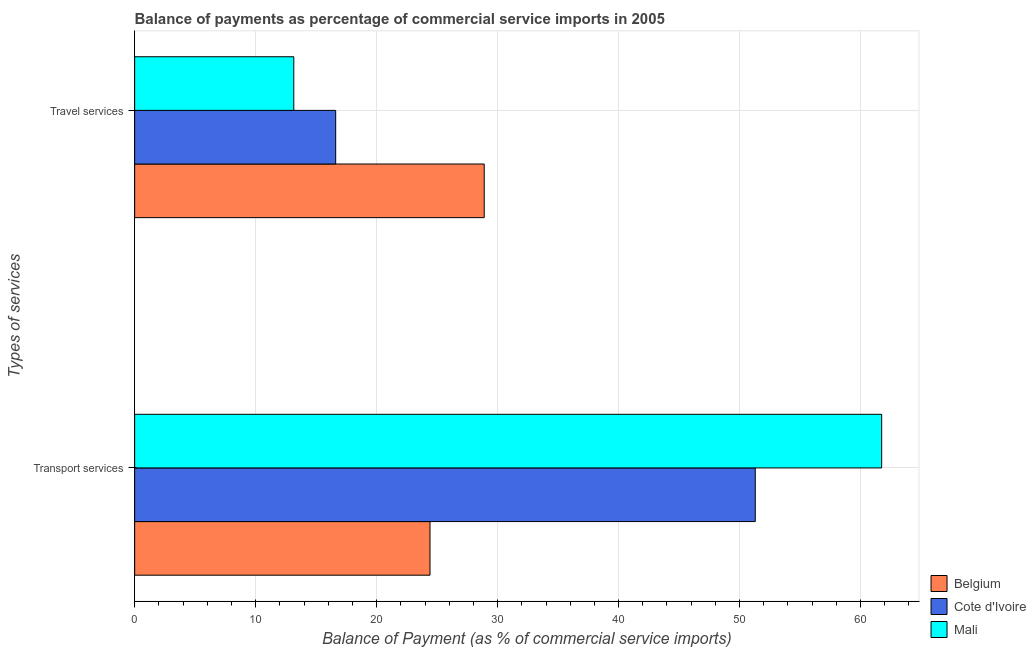How many groups of bars are there?
Your answer should be compact. 2. Are the number of bars per tick equal to the number of legend labels?
Provide a short and direct response. Yes. Are the number of bars on each tick of the Y-axis equal?
Ensure brevity in your answer.  Yes. How many bars are there on the 1st tick from the top?
Ensure brevity in your answer.  3. How many bars are there on the 1st tick from the bottom?
Provide a short and direct response. 3. What is the label of the 2nd group of bars from the top?
Make the answer very short. Transport services. What is the balance of payments of transport services in Belgium?
Give a very brief answer. 24.41. Across all countries, what is the maximum balance of payments of transport services?
Your response must be concise. 61.74. Across all countries, what is the minimum balance of payments of travel services?
Provide a succinct answer. 13.15. In which country was the balance of payments of transport services maximum?
Keep it short and to the point. Mali. In which country was the balance of payments of transport services minimum?
Offer a terse response. Belgium. What is the total balance of payments of travel services in the graph?
Your response must be concise. 58.66. What is the difference between the balance of payments of travel services in Cote d'Ivoire and that in Mali?
Ensure brevity in your answer.  3.46. What is the difference between the balance of payments of transport services in Belgium and the balance of payments of travel services in Mali?
Offer a very short reply. 11.26. What is the average balance of payments of travel services per country?
Provide a succinct answer. 19.55. What is the difference between the balance of payments of transport services and balance of payments of travel services in Cote d'Ivoire?
Provide a succinct answer. 34.68. In how many countries, is the balance of payments of transport services greater than 48 %?
Your response must be concise. 2. What is the ratio of the balance of payments of travel services in Mali to that in Cote d'Ivoire?
Ensure brevity in your answer.  0.79. What does the 2nd bar from the top in Transport services represents?
Ensure brevity in your answer.  Cote d'Ivoire. What does the 3rd bar from the bottom in Travel services represents?
Your answer should be very brief. Mali. How many bars are there?
Provide a succinct answer. 6. Are all the bars in the graph horizontal?
Provide a short and direct response. Yes. What is the difference between two consecutive major ticks on the X-axis?
Provide a short and direct response. 10. Does the graph contain grids?
Your response must be concise. Yes. How many legend labels are there?
Your answer should be very brief. 3. How are the legend labels stacked?
Offer a very short reply. Vertical. What is the title of the graph?
Ensure brevity in your answer.  Balance of payments as percentage of commercial service imports in 2005. What is the label or title of the X-axis?
Offer a terse response. Balance of Payment (as % of commercial service imports). What is the label or title of the Y-axis?
Provide a succinct answer. Types of services. What is the Balance of Payment (as % of commercial service imports) of Belgium in Transport services?
Ensure brevity in your answer.  24.41. What is the Balance of Payment (as % of commercial service imports) of Cote d'Ivoire in Transport services?
Your answer should be very brief. 51.3. What is the Balance of Payment (as % of commercial service imports) of Mali in Transport services?
Ensure brevity in your answer.  61.74. What is the Balance of Payment (as % of commercial service imports) of Belgium in Travel services?
Offer a very short reply. 28.89. What is the Balance of Payment (as % of commercial service imports) in Cote d'Ivoire in Travel services?
Offer a terse response. 16.62. What is the Balance of Payment (as % of commercial service imports) of Mali in Travel services?
Your response must be concise. 13.15. Across all Types of services, what is the maximum Balance of Payment (as % of commercial service imports) of Belgium?
Your response must be concise. 28.89. Across all Types of services, what is the maximum Balance of Payment (as % of commercial service imports) of Cote d'Ivoire?
Give a very brief answer. 51.3. Across all Types of services, what is the maximum Balance of Payment (as % of commercial service imports) in Mali?
Give a very brief answer. 61.74. Across all Types of services, what is the minimum Balance of Payment (as % of commercial service imports) in Belgium?
Provide a succinct answer. 24.41. Across all Types of services, what is the minimum Balance of Payment (as % of commercial service imports) of Cote d'Ivoire?
Offer a terse response. 16.62. Across all Types of services, what is the minimum Balance of Payment (as % of commercial service imports) of Mali?
Keep it short and to the point. 13.15. What is the total Balance of Payment (as % of commercial service imports) of Belgium in the graph?
Ensure brevity in your answer.  53.31. What is the total Balance of Payment (as % of commercial service imports) of Cote d'Ivoire in the graph?
Provide a short and direct response. 67.91. What is the total Balance of Payment (as % of commercial service imports) of Mali in the graph?
Provide a short and direct response. 74.9. What is the difference between the Balance of Payment (as % of commercial service imports) of Belgium in Transport services and that in Travel services?
Provide a short and direct response. -4.48. What is the difference between the Balance of Payment (as % of commercial service imports) in Cote d'Ivoire in Transport services and that in Travel services?
Give a very brief answer. 34.68. What is the difference between the Balance of Payment (as % of commercial service imports) of Mali in Transport services and that in Travel services?
Offer a very short reply. 48.59. What is the difference between the Balance of Payment (as % of commercial service imports) in Belgium in Transport services and the Balance of Payment (as % of commercial service imports) in Cote d'Ivoire in Travel services?
Make the answer very short. 7.8. What is the difference between the Balance of Payment (as % of commercial service imports) in Belgium in Transport services and the Balance of Payment (as % of commercial service imports) in Mali in Travel services?
Provide a short and direct response. 11.26. What is the difference between the Balance of Payment (as % of commercial service imports) of Cote d'Ivoire in Transport services and the Balance of Payment (as % of commercial service imports) of Mali in Travel services?
Your answer should be very brief. 38.14. What is the average Balance of Payment (as % of commercial service imports) of Belgium per Types of services?
Provide a short and direct response. 26.65. What is the average Balance of Payment (as % of commercial service imports) of Cote d'Ivoire per Types of services?
Your response must be concise. 33.96. What is the average Balance of Payment (as % of commercial service imports) in Mali per Types of services?
Give a very brief answer. 37.45. What is the difference between the Balance of Payment (as % of commercial service imports) in Belgium and Balance of Payment (as % of commercial service imports) in Cote d'Ivoire in Transport services?
Your response must be concise. -26.88. What is the difference between the Balance of Payment (as % of commercial service imports) of Belgium and Balance of Payment (as % of commercial service imports) of Mali in Transport services?
Your answer should be very brief. -37.33. What is the difference between the Balance of Payment (as % of commercial service imports) in Cote d'Ivoire and Balance of Payment (as % of commercial service imports) in Mali in Transport services?
Provide a short and direct response. -10.45. What is the difference between the Balance of Payment (as % of commercial service imports) of Belgium and Balance of Payment (as % of commercial service imports) of Cote d'Ivoire in Travel services?
Your response must be concise. 12.28. What is the difference between the Balance of Payment (as % of commercial service imports) of Belgium and Balance of Payment (as % of commercial service imports) of Mali in Travel services?
Ensure brevity in your answer.  15.74. What is the difference between the Balance of Payment (as % of commercial service imports) in Cote d'Ivoire and Balance of Payment (as % of commercial service imports) in Mali in Travel services?
Give a very brief answer. 3.46. What is the ratio of the Balance of Payment (as % of commercial service imports) of Belgium in Transport services to that in Travel services?
Your answer should be very brief. 0.84. What is the ratio of the Balance of Payment (as % of commercial service imports) in Cote d'Ivoire in Transport services to that in Travel services?
Provide a short and direct response. 3.09. What is the ratio of the Balance of Payment (as % of commercial service imports) in Mali in Transport services to that in Travel services?
Your answer should be compact. 4.69. What is the difference between the highest and the second highest Balance of Payment (as % of commercial service imports) in Belgium?
Your answer should be very brief. 4.48. What is the difference between the highest and the second highest Balance of Payment (as % of commercial service imports) in Cote d'Ivoire?
Provide a succinct answer. 34.68. What is the difference between the highest and the second highest Balance of Payment (as % of commercial service imports) in Mali?
Provide a short and direct response. 48.59. What is the difference between the highest and the lowest Balance of Payment (as % of commercial service imports) in Belgium?
Offer a very short reply. 4.48. What is the difference between the highest and the lowest Balance of Payment (as % of commercial service imports) of Cote d'Ivoire?
Keep it short and to the point. 34.68. What is the difference between the highest and the lowest Balance of Payment (as % of commercial service imports) in Mali?
Keep it short and to the point. 48.59. 